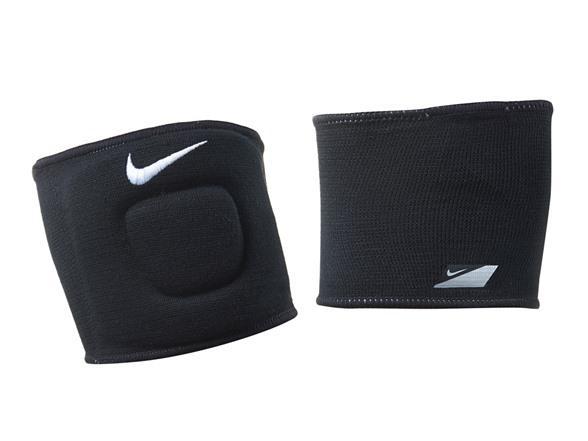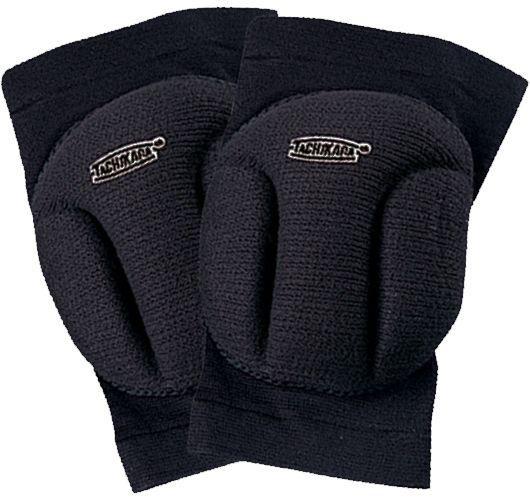The first image is the image on the left, the second image is the image on the right. Assess this claim about the two images: "Three pads are black and one is white.". Correct or not? Answer yes or no. No. 